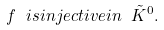<formula> <loc_0><loc_0><loc_500><loc_500>f \ i s i n j e c t i v e i n \ \tilde { K } ^ { 0 } .</formula> 